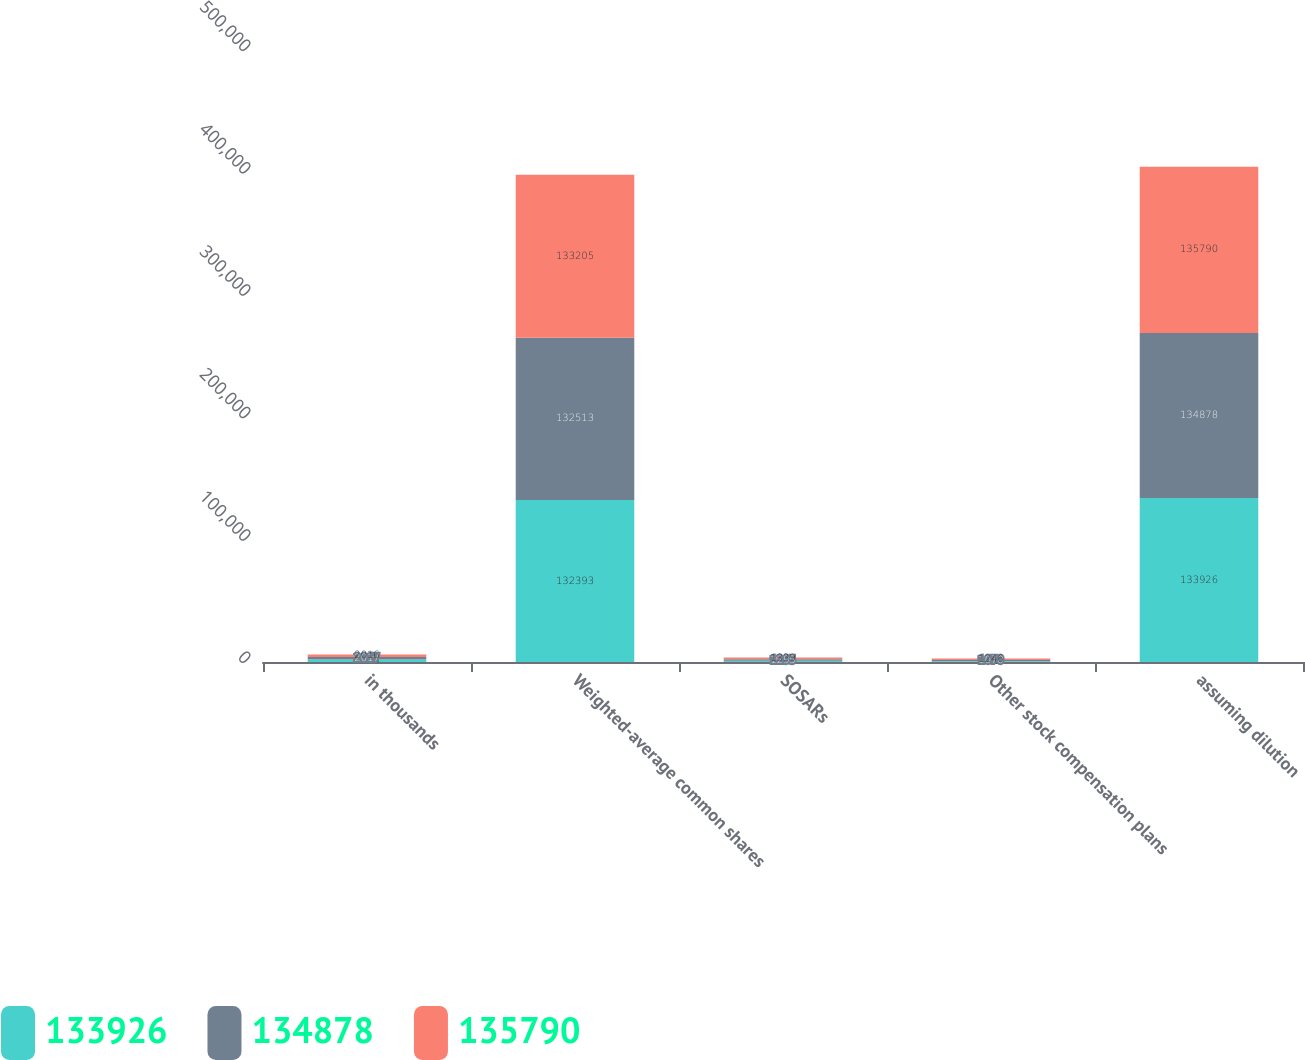<chart> <loc_0><loc_0><loc_500><loc_500><stacked_bar_chart><ecel><fcel>in thousands<fcel>Weighted-average common shares<fcel>SOSARs<fcel>Other stock compensation plans<fcel>assuming dilution<nl><fcel>133926<fcel>2018<fcel>132393<fcel>963<fcel>570<fcel>133926<nl><fcel>134878<fcel>2017<fcel>132513<fcel>1295<fcel>1070<fcel>134878<nl><fcel>135790<fcel>2016<fcel>133205<fcel>1339<fcel>1246<fcel>135790<nl></chart> 